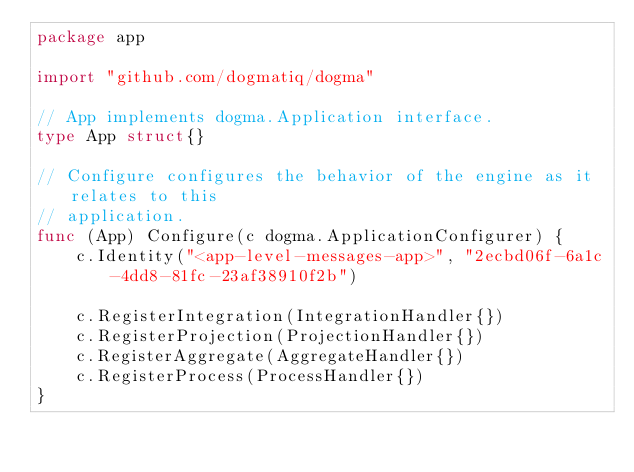Convert code to text. <code><loc_0><loc_0><loc_500><loc_500><_Go_>package app

import "github.com/dogmatiq/dogma"

// App implements dogma.Application interface.
type App struct{}

// Configure configures the behavior of the engine as it relates to this
// application.
func (App) Configure(c dogma.ApplicationConfigurer) {
	c.Identity("<app-level-messages-app>", "2ecbd06f-6a1c-4dd8-81fc-23af38910f2b")

	c.RegisterIntegration(IntegrationHandler{})
	c.RegisterProjection(ProjectionHandler{})
	c.RegisterAggregate(AggregateHandler{})
	c.RegisterProcess(ProcessHandler{})
}
</code> 